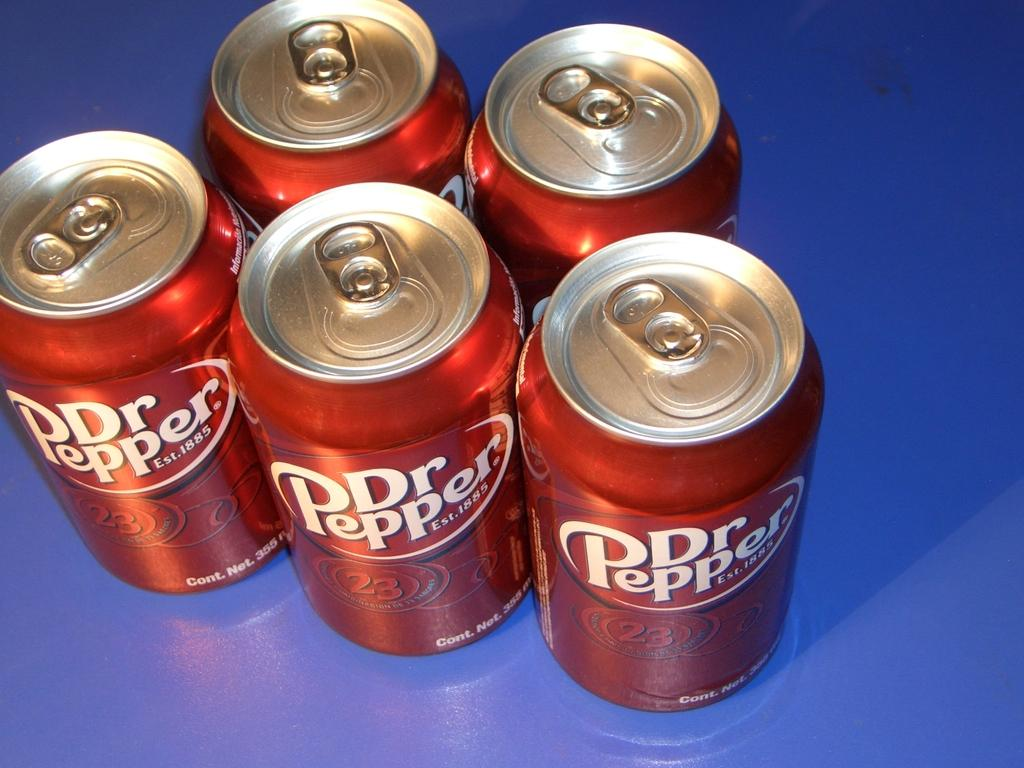<image>
Create a compact narrative representing the image presented. Five cans of Dr Pepper, two on top and three on the bottom 